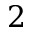Convert formula to latex. <formula><loc_0><loc_0><loc_500><loc_500>2</formula> 